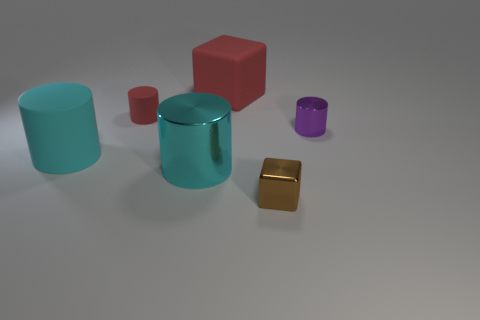There is a cyan rubber thing; what number of large cyan matte cylinders are on the left side of it?
Your response must be concise. 0. How many other things are there of the same shape as the big red matte object?
Ensure brevity in your answer.  1. Are there fewer tiny objects than small purple shiny cylinders?
Offer a terse response. No. There is a cylinder that is both right of the small red matte cylinder and on the left side of the large cube; how big is it?
Give a very brief answer. Large. There is a shiny object behind the metallic object that is left of the tiny thing in front of the big cyan matte thing; how big is it?
Give a very brief answer. Small. What size is the red matte cube?
Ensure brevity in your answer.  Large. Is there any other thing that has the same material as the tiny brown thing?
Make the answer very short. Yes. Are there any purple shiny cylinders to the left of the shiny object to the right of the cube that is in front of the rubber cube?
Keep it short and to the point. No. How many big things are cyan rubber objects or brown objects?
Your response must be concise. 1. Are there any other things that have the same color as the large metal object?
Ensure brevity in your answer.  Yes. 